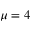Convert formula to latex. <formula><loc_0><loc_0><loc_500><loc_500>\mu = 4</formula> 